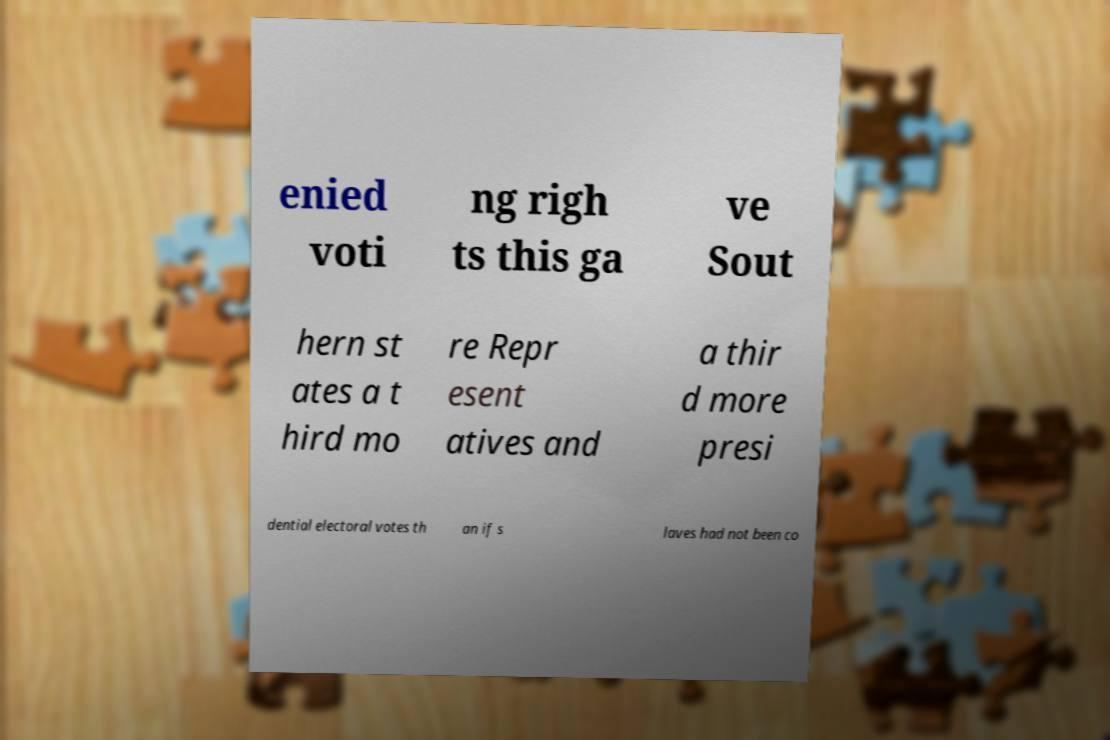Please read and relay the text visible in this image. What does it say? enied voti ng righ ts this ga ve Sout hern st ates a t hird mo re Repr esent atives and a thir d more presi dential electoral votes th an if s laves had not been co 